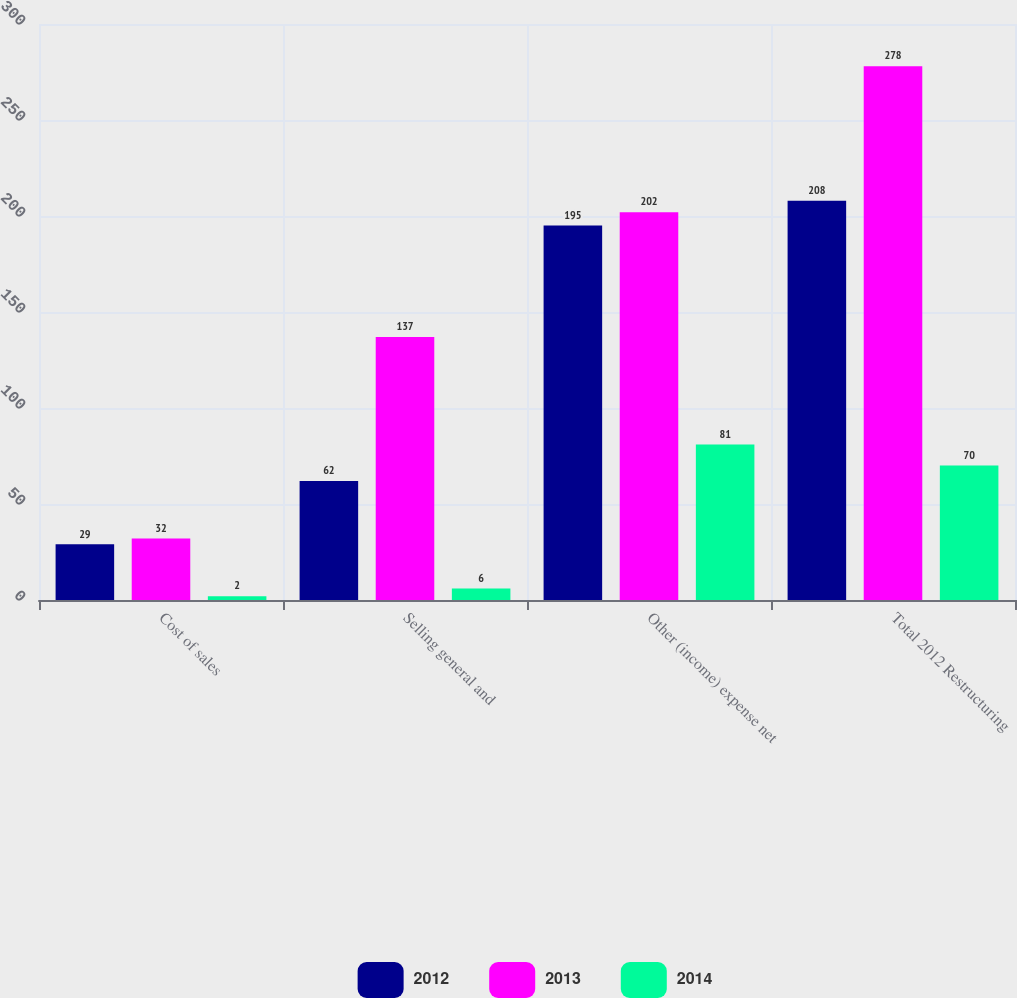Convert chart to OTSL. <chart><loc_0><loc_0><loc_500><loc_500><stacked_bar_chart><ecel><fcel>Cost of sales<fcel>Selling general and<fcel>Other (income) expense net<fcel>Total 2012 Restructuring<nl><fcel>2012<fcel>29<fcel>62<fcel>195<fcel>208<nl><fcel>2013<fcel>32<fcel>137<fcel>202<fcel>278<nl><fcel>2014<fcel>2<fcel>6<fcel>81<fcel>70<nl></chart> 